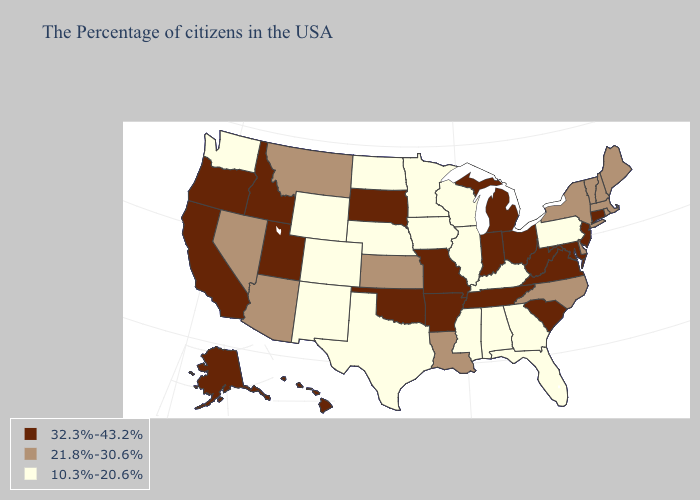Name the states that have a value in the range 10.3%-20.6%?
Be succinct. Pennsylvania, Florida, Georgia, Kentucky, Alabama, Wisconsin, Illinois, Mississippi, Minnesota, Iowa, Nebraska, Texas, North Dakota, Wyoming, Colorado, New Mexico, Washington. Name the states that have a value in the range 10.3%-20.6%?
Write a very short answer. Pennsylvania, Florida, Georgia, Kentucky, Alabama, Wisconsin, Illinois, Mississippi, Minnesota, Iowa, Nebraska, Texas, North Dakota, Wyoming, Colorado, New Mexico, Washington. Name the states that have a value in the range 32.3%-43.2%?
Short answer required. Connecticut, New Jersey, Maryland, Virginia, South Carolina, West Virginia, Ohio, Michigan, Indiana, Tennessee, Missouri, Arkansas, Oklahoma, South Dakota, Utah, Idaho, California, Oregon, Alaska, Hawaii. What is the highest value in states that border Nevada?
Quick response, please. 32.3%-43.2%. Does New York have a higher value than Wyoming?
Keep it brief. Yes. Does the map have missing data?
Write a very short answer. No. Among the states that border Nevada , does Utah have the highest value?
Be succinct. Yes. What is the highest value in the West ?
Answer briefly. 32.3%-43.2%. Is the legend a continuous bar?
Concise answer only. No. Among the states that border Delaware , which have the lowest value?
Give a very brief answer. Pennsylvania. What is the value of Arkansas?
Quick response, please. 32.3%-43.2%. What is the highest value in states that border North Carolina?
Write a very short answer. 32.3%-43.2%. Does South Carolina have the lowest value in the South?
Answer briefly. No. Does Iowa have a lower value than Colorado?
Quick response, please. No. Does Kentucky have a lower value than Montana?
Answer briefly. Yes. 